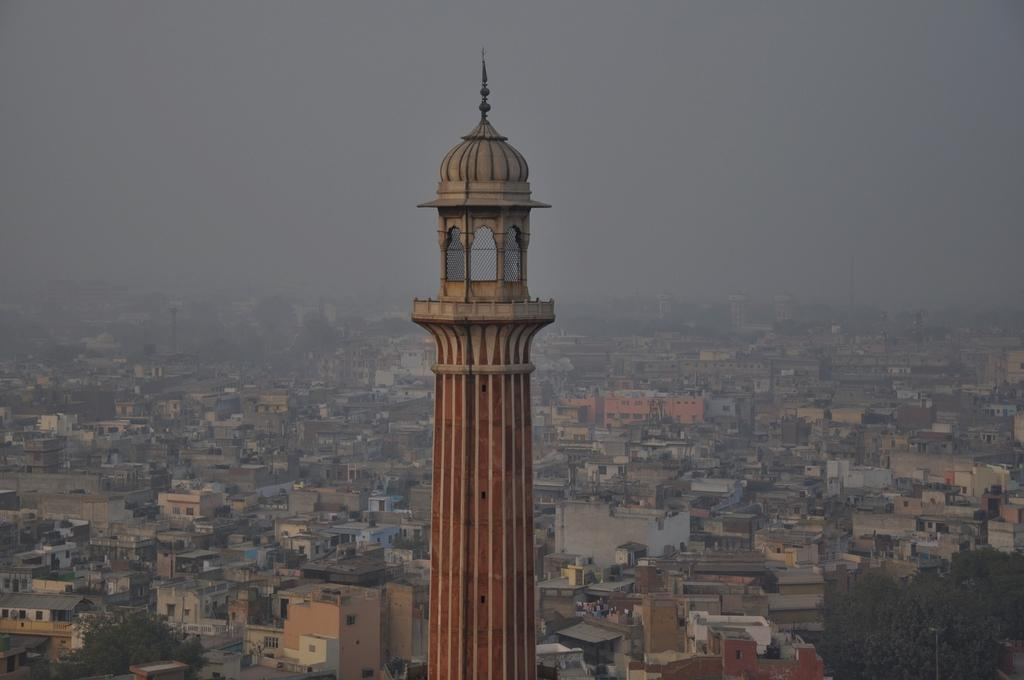What is the main structure in the foreground of the image? There is a tower in the foreground of the image. What else can be seen behind the tower? There is a group of buildings behind the tower. What type of vegetation is visible in the image? There are trees visible in the image. What is visible at the top of the image? The sky is visible at the top of the image. How many cribs are visible in the image? There are no cribs present in the image. Are there any police officers visible in the image? There is no indication of police officers in the image. 